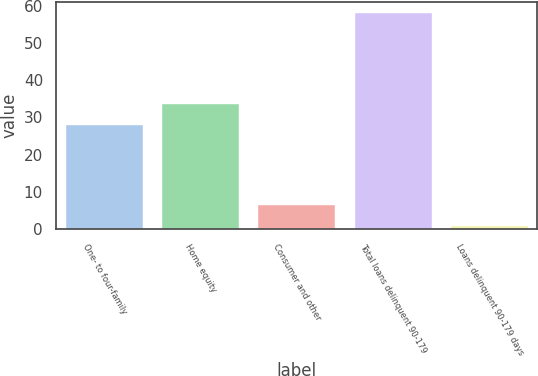Convert chart. <chart><loc_0><loc_0><loc_500><loc_500><bar_chart><fcel>One- to four-family<fcel>Home equity<fcel>Consumer and other<fcel>Total loans delinquent 90-179<fcel>Loans delinquent 90-179 days<nl><fcel>28<fcel>33.71<fcel>6.61<fcel>58<fcel>0.9<nl></chart> 